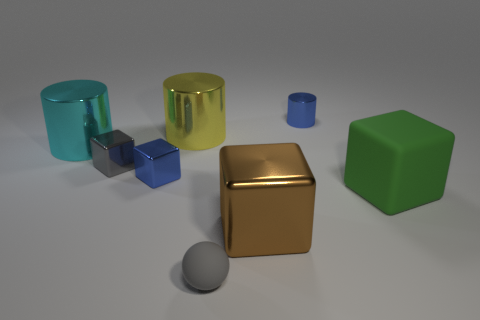Add 2 big cyan metallic cylinders. How many objects exist? 10 Subtract all balls. How many objects are left? 7 Subtract all large objects. Subtract all cyan shiny cylinders. How many objects are left? 3 Add 4 cyan cylinders. How many cyan cylinders are left? 5 Add 7 matte spheres. How many matte spheres exist? 8 Subtract 0 brown cylinders. How many objects are left? 8 